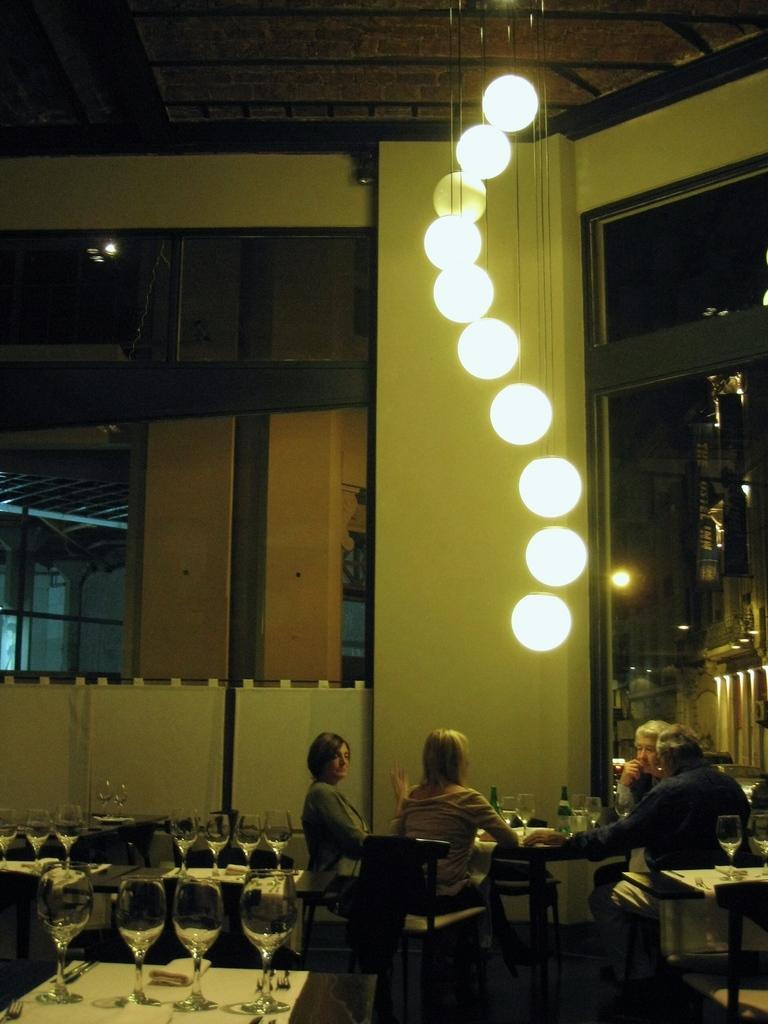In one or two sentences, can you explain what this image depicts? These four persons are sitting on the chairs. We can see glasses,bottles on the tables. On the top we can see lights. On the background we can see wall,glass window. 